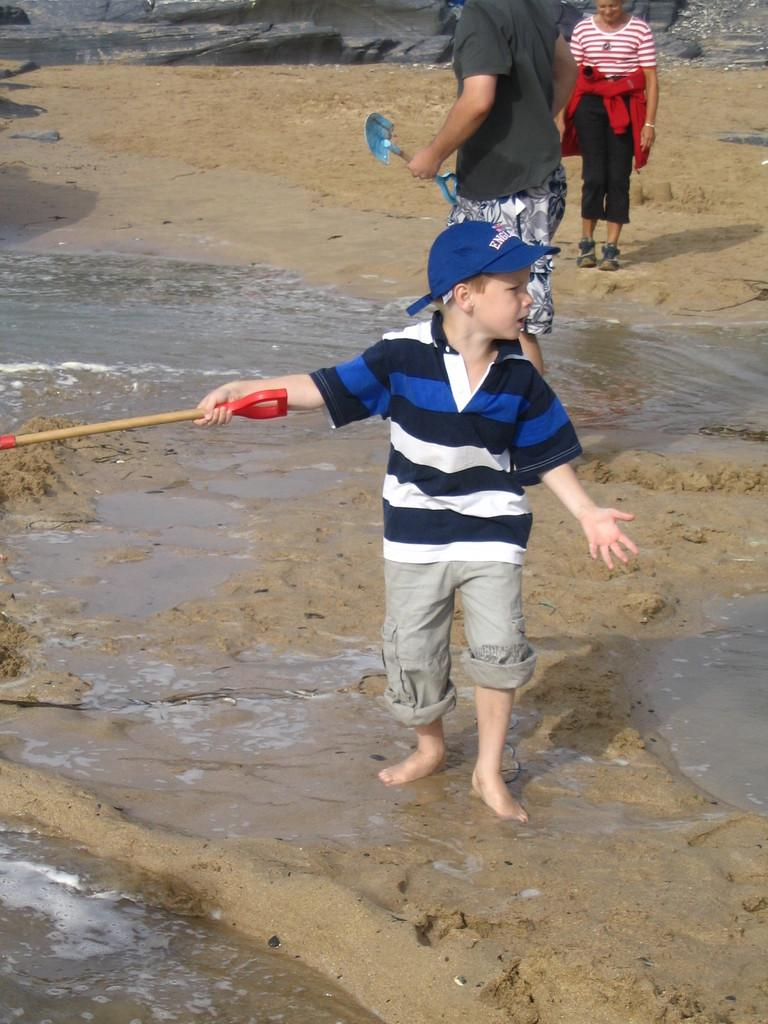Who or what can be seen in the image? There are people in the image. What are some of the people doing in the image? Some people are holding objects. What type of environment is depicted in the image? There is water and sand visible in the image, suggesting a beach or coastal setting. What color is the orange that the people are holding in the image? There is no orange present in the image; the people are holding unspecified objects. 